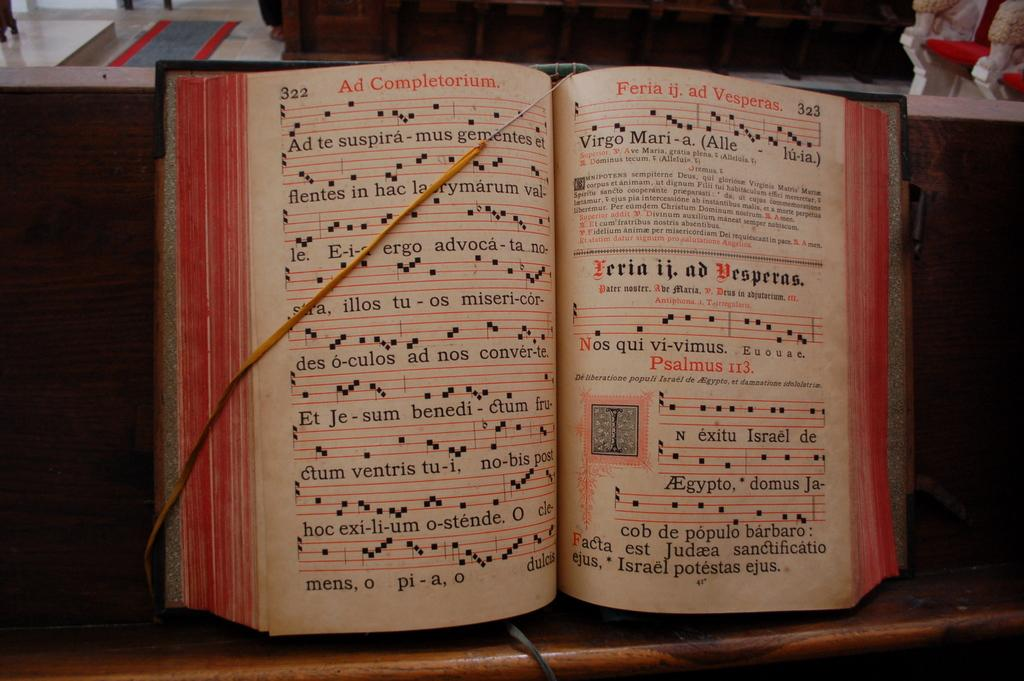What object can be seen in the image? There is a book in the image. What is written or printed on the book? The book has text on it. On what surface is the book placed? The book is placed on a wooden surface. What type of record is being played in the image? There is no record player or record visible in the image; it only features a book placed on a wooden surface. Can you see a cat in the image? No, there is no cat present in the image. 